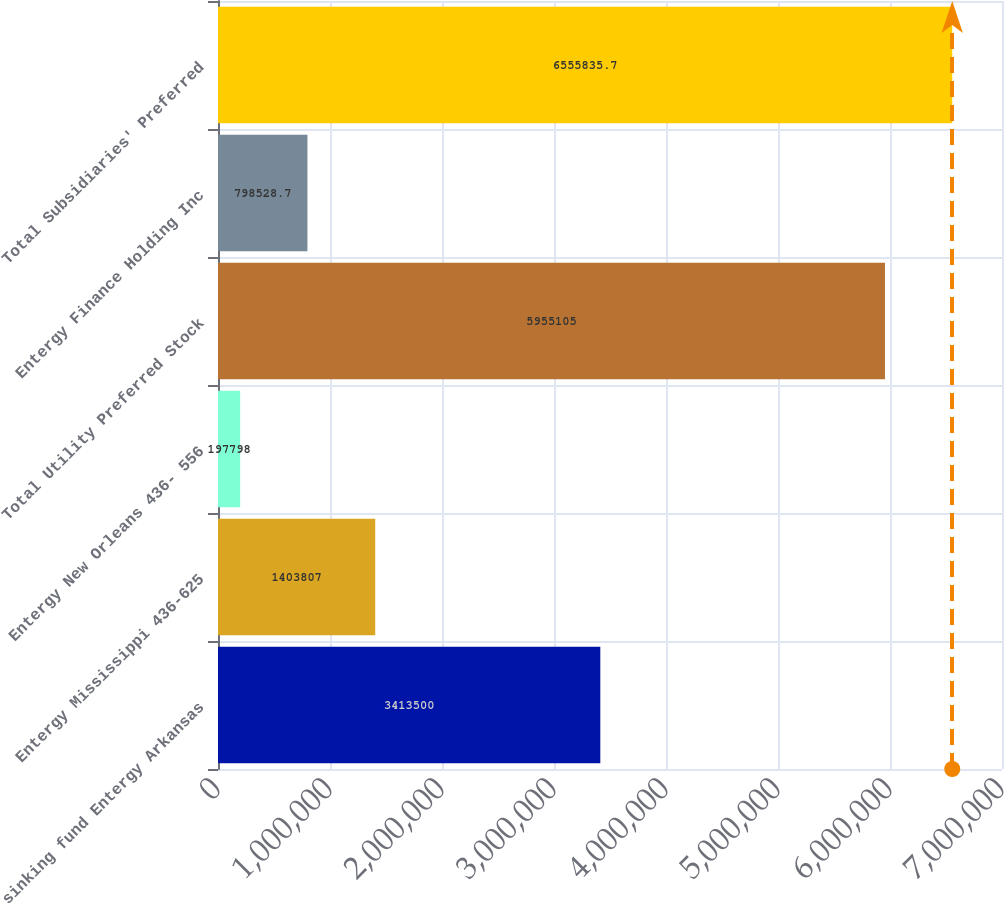<chart> <loc_0><loc_0><loc_500><loc_500><bar_chart><fcel>sinking fund Entergy Arkansas<fcel>Entergy Mississippi 436-625<fcel>Entergy New Orleans 436- 556<fcel>Total Utility Preferred Stock<fcel>Entergy Finance Holding Inc<fcel>Total Subsidiaries' Preferred<nl><fcel>3.4135e+06<fcel>1.40381e+06<fcel>197798<fcel>5.9551e+06<fcel>798529<fcel>6.55584e+06<nl></chart> 